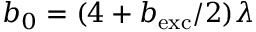<formula> <loc_0><loc_0><loc_500><loc_500>b _ { 0 } = ( 4 + b _ { e x c } / 2 ) \lambda</formula> 